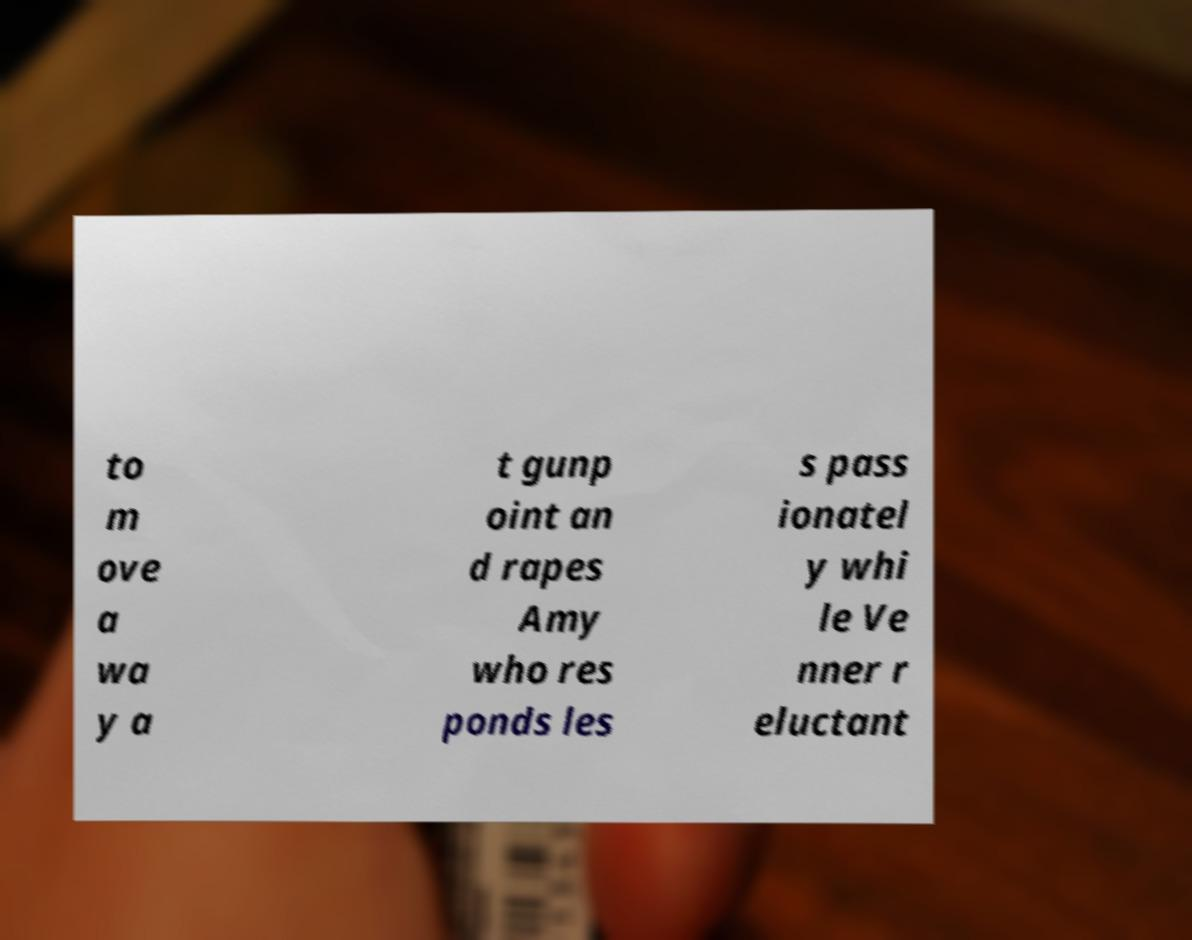What messages or text are displayed in this image? I need them in a readable, typed format. to m ove a wa y a t gunp oint an d rapes Amy who res ponds les s pass ionatel y whi le Ve nner r eluctant 